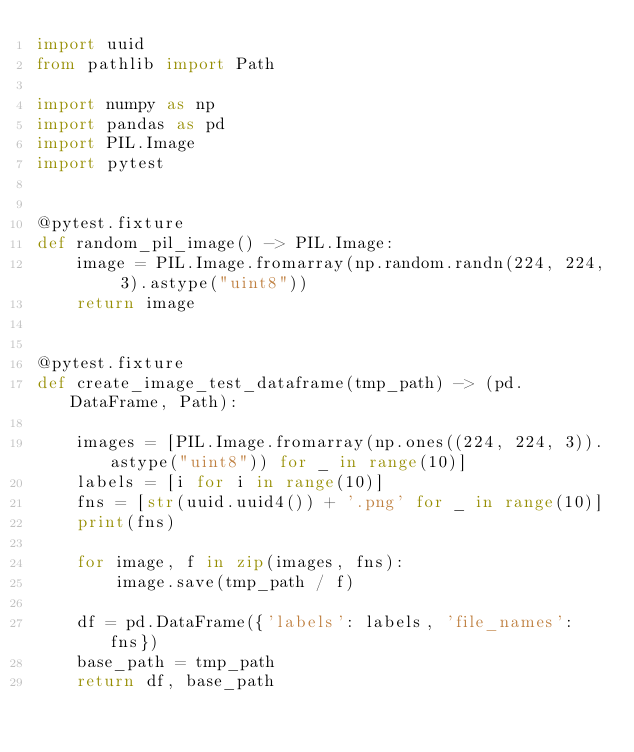Convert code to text. <code><loc_0><loc_0><loc_500><loc_500><_Python_>import uuid
from pathlib import Path

import numpy as np
import pandas as pd
import PIL.Image
import pytest


@pytest.fixture
def random_pil_image() -> PIL.Image:
    image = PIL.Image.fromarray(np.random.randn(224, 224, 3).astype("uint8"))
    return image


@pytest.fixture
def create_image_test_dataframe(tmp_path) -> (pd.DataFrame, Path):

    images = [PIL.Image.fromarray(np.ones((224, 224, 3)).astype("uint8")) for _ in range(10)]
    labels = [i for i in range(10)]
    fns = [str(uuid.uuid4()) + '.png' for _ in range(10)]
    print(fns)

    for image, f in zip(images, fns):
        image.save(tmp_path / f)

    df = pd.DataFrame({'labels': labels, 'file_names': fns})
    base_path = tmp_path
    return df, base_path
</code> 